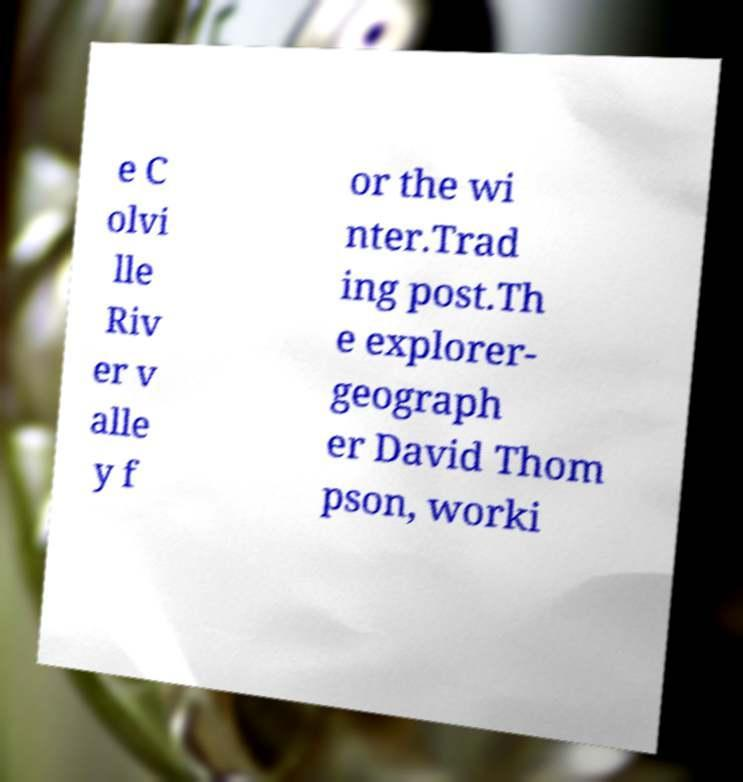Please read and relay the text visible in this image. What does it say? e C olvi lle Riv er v alle y f or the wi nter.Trad ing post.Th e explorer- geograph er David Thom pson, worki 